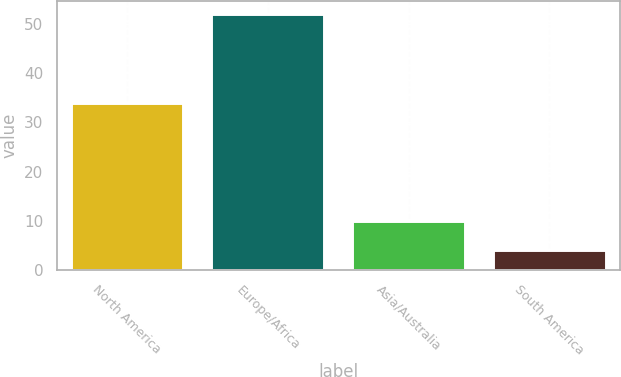Convert chart to OTSL. <chart><loc_0><loc_0><loc_500><loc_500><bar_chart><fcel>North America<fcel>Europe/Africa<fcel>Asia/Australia<fcel>South America<nl><fcel>34<fcel>52<fcel>10<fcel>4<nl></chart> 